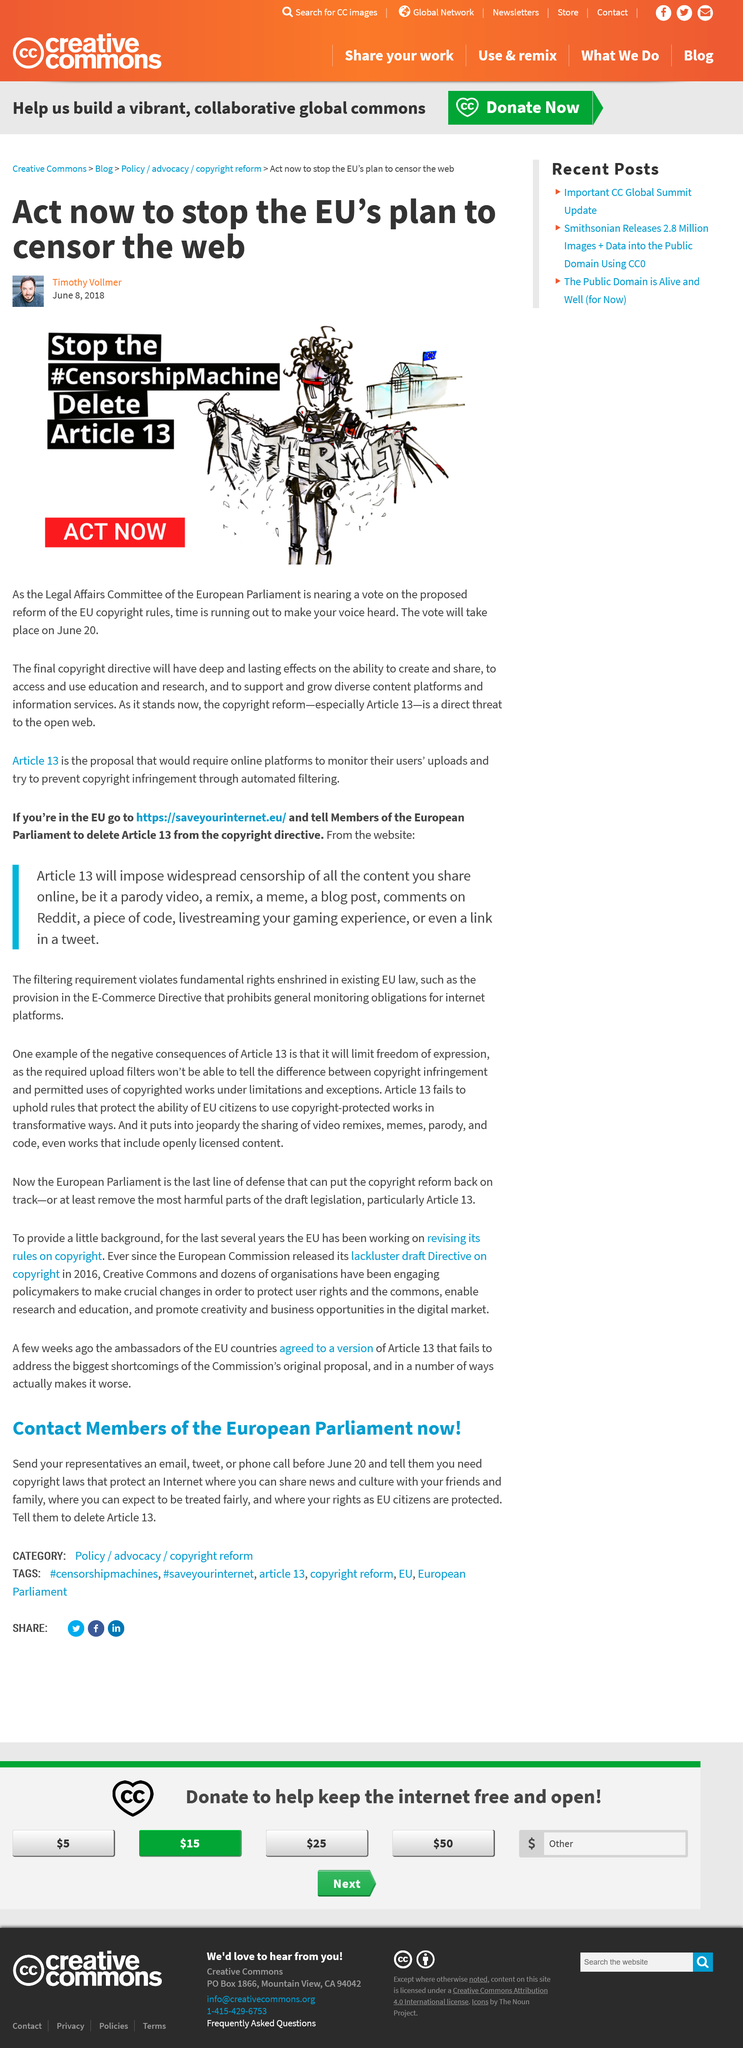List a handful of essential elements in this visual. Article 13 has the potential to significantly impact the creation, sharing, access, and use of education and research, as well as the growth and support of diverse content platforms and information services, with long-lasting effects on the ability to do so. The threat to current European copyright laws is the possible introduction of Article 13, which could have significant implications for creators, users, and the broader digital ecosystem. The European Parliament's Legal Affairs Committee is currently deliberating the implementation of Article 13. 